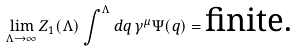Convert formula to latex. <formula><loc_0><loc_0><loc_500><loc_500>\lim _ { \Lambda \to \infty } Z _ { 1 } ( \Lambda ) \int ^ { \Lambda } d { q } \, \gamma ^ { \mu } \Psi ( { q } ) = \text {finite.}</formula> 